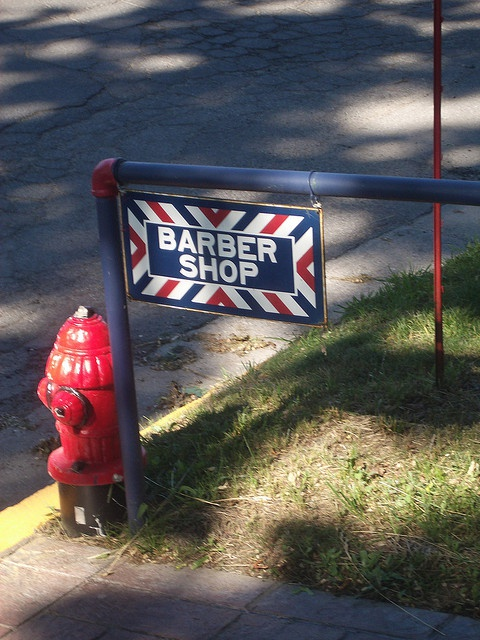Describe the objects in this image and their specific colors. I can see a fire hydrant in darkgray, maroon, black, salmon, and brown tones in this image. 